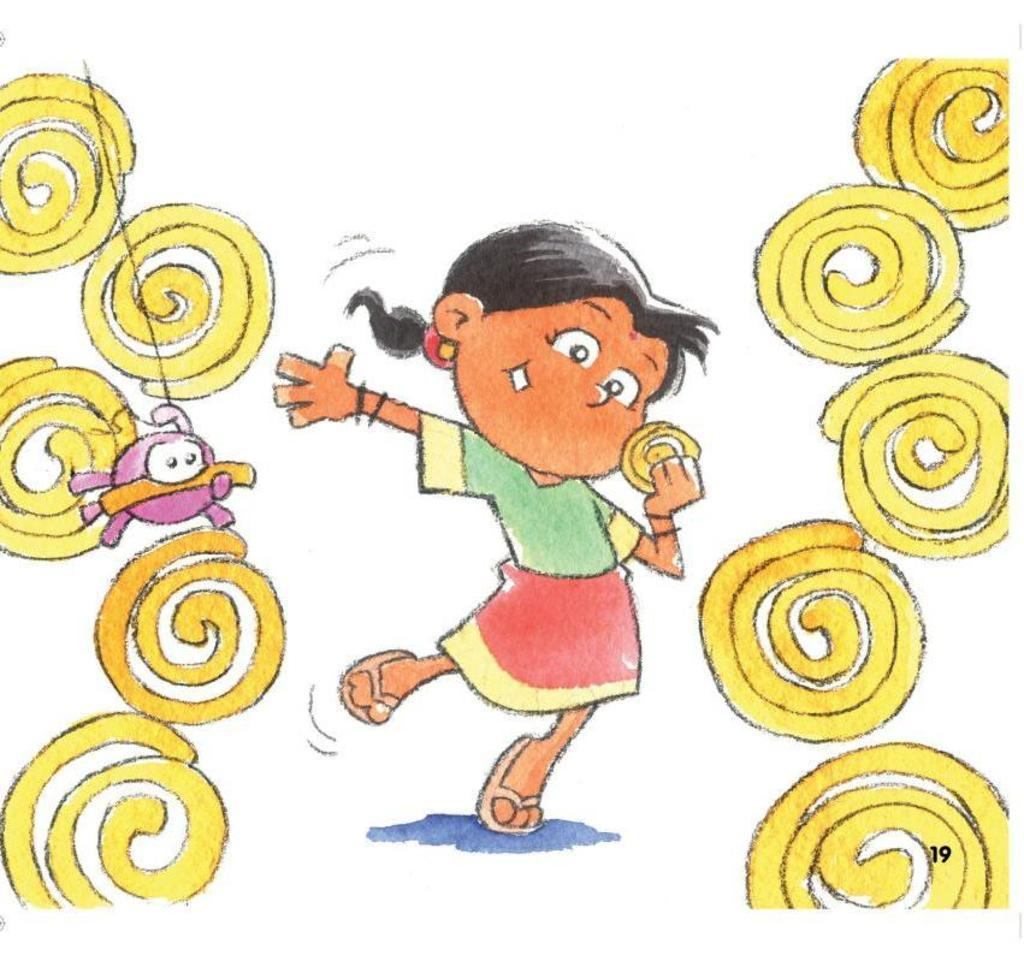What is depicted in the image? There is a drawing of a child in the image. What is the child doing in the drawing? The child is holding an object in the drawing. What else can be seen in the image besides the child? There are other objects present in the image. What type of treatment is the child receiving for their shoes in the image? There is no mention of shoes or any treatment in the image; it is a drawing of a child holding an object. 